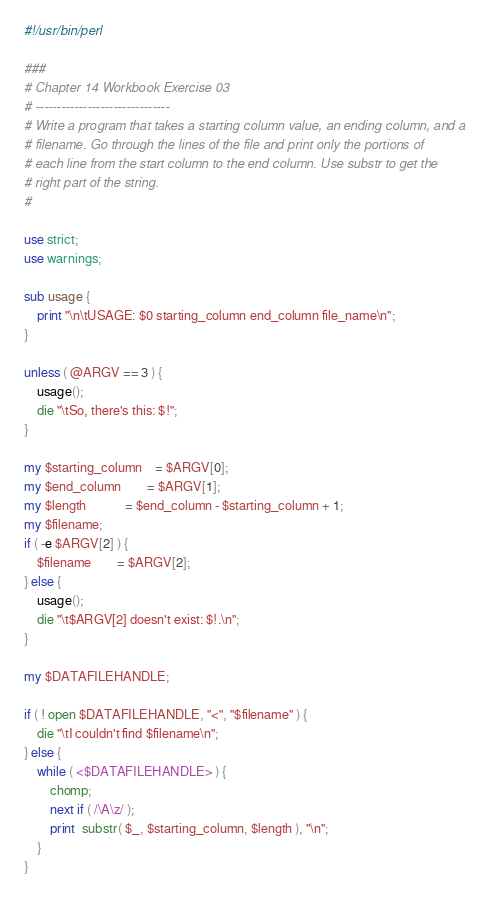<code> <loc_0><loc_0><loc_500><loc_500><_Perl_>#!/usr/bin/perl

###
# Chapter 14 Workbook Exercise 03
# -------------------------------
# Write a program that takes a starting column value, an ending column, and a 
# filename. Go through the lines of the file and print only the portions of 
# each line from the start column to the end column. Use substr to get the 
# right part of the string.
#

use strict;
use warnings;

sub usage {
	print "\n\tUSAGE: $0 starting_column end_column file_name\n";
}

unless ( @ARGV == 3 ) {
	usage();
	die "\tSo, there's this: $!";
}

my $starting_column	= $ARGV[0];
my $end_column		= $ARGV[1];
my $length 			= $end_column - $starting_column + 1;
my $filename;
if ( -e $ARGV[2] ) {
	$filename 		= $ARGV[2];
} else {
	usage();
	die "\t$ARGV[2] doesn't exist: $!.\n";
}

my $DATAFILEHANDLE;

if ( ! open $DATAFILEHANDLE, "<", "$filename" ) {
	die "\tI couldn't find $filename\n";
} else {
	while ( <$DATAFILEHANDLE> ) {
		chomp;
		next if ( /\A\z/ );
		print  substr( $_, $starting_column, $length ), "\n";
	}
}</code> 